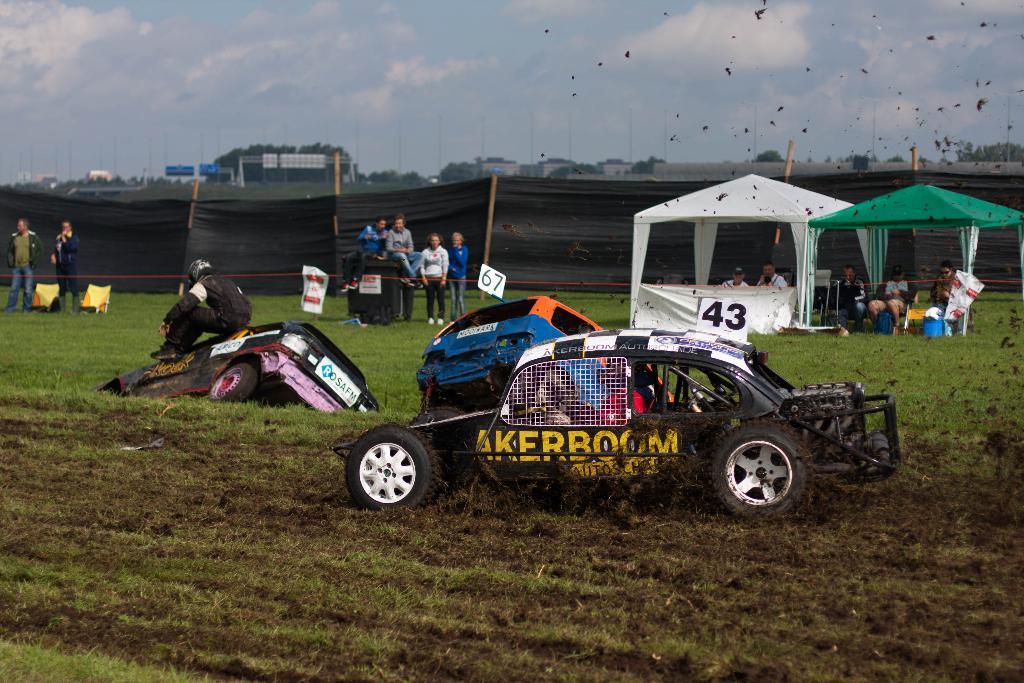Describe this image in one or two sentences. In this picture I can see few vehicles are on the grass, side there are some tents and also I can see few people around. 